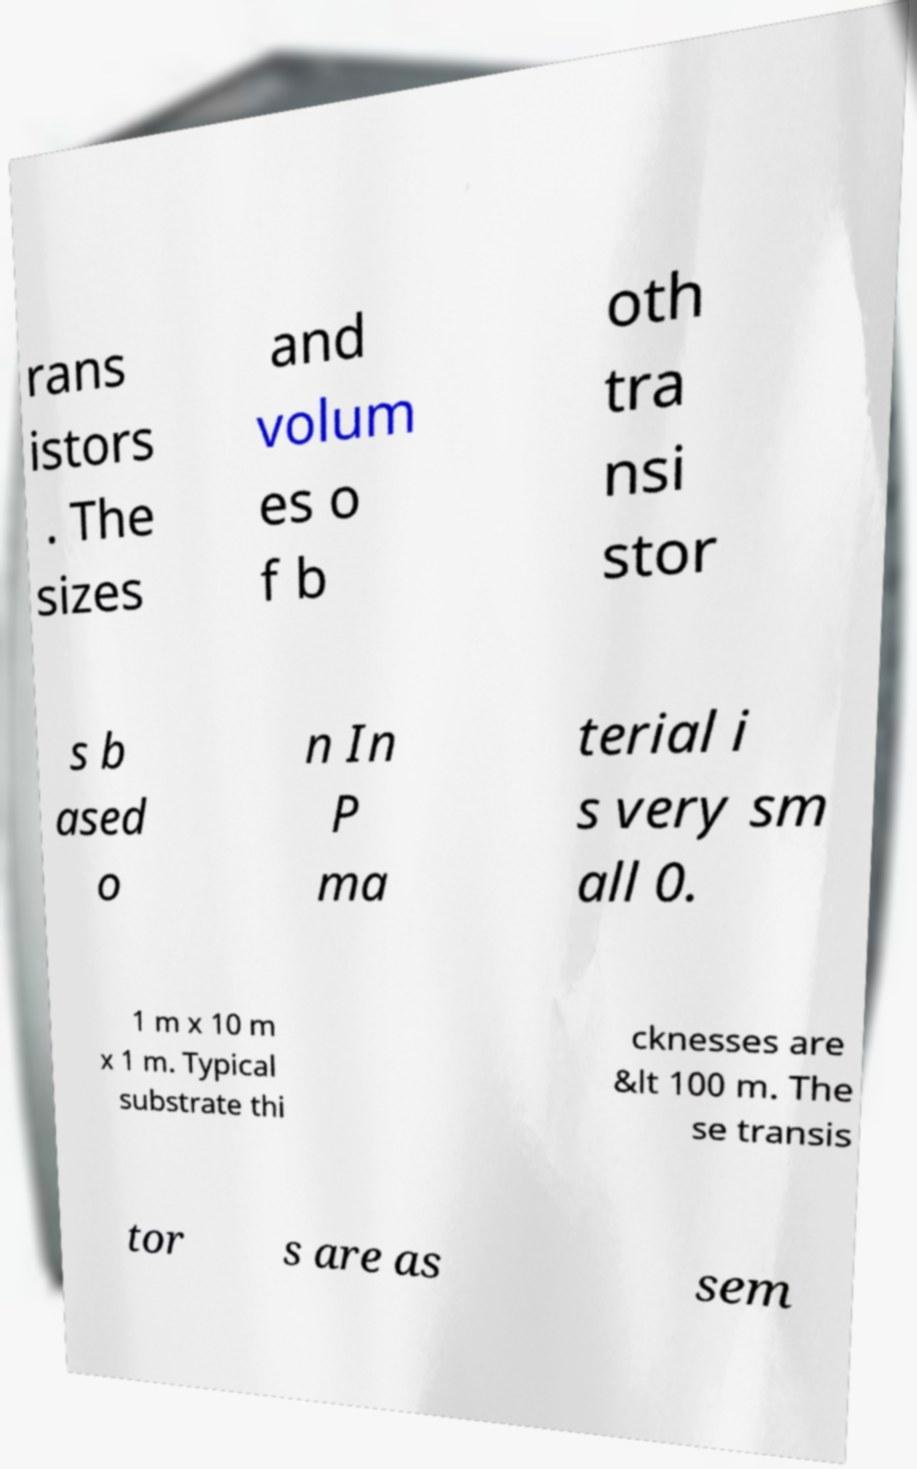Could you assist in decoding the text presented in this image and type it out clearly? rans istors . The sizes and volum es o f b oth tra nsi stor s b ased o n In P ma terial i s very sm all 0. 1 m x 10 m x 1 m. Typical substrate thi cknesses are &lt 100 m. The se transis tor s are as sem 